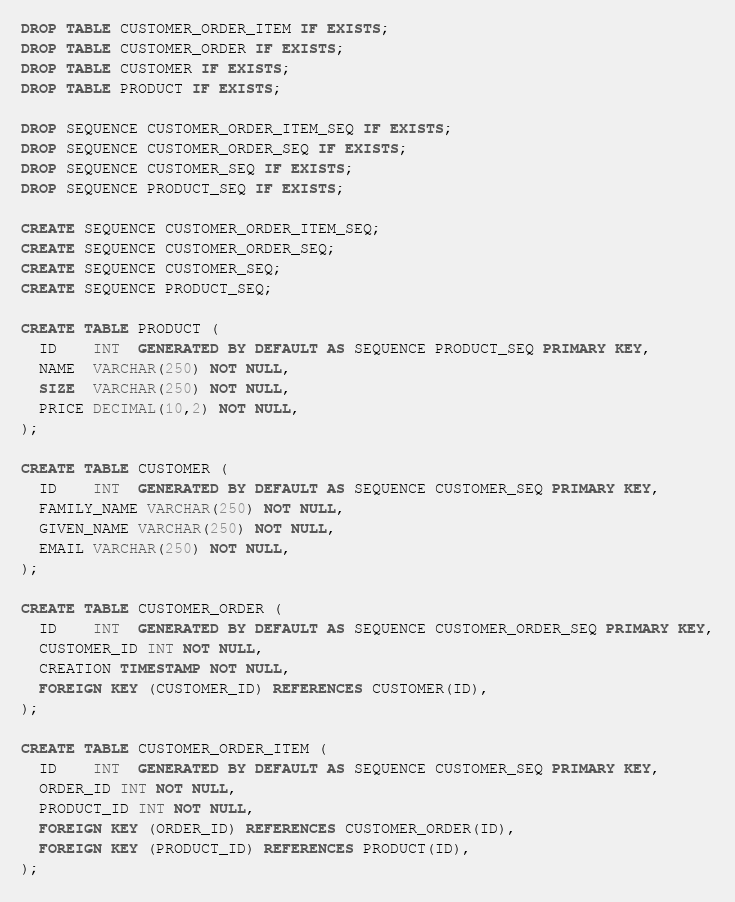Convert code to text. <code><loc_0><loc_0><loc_500><loc_500><_SQL_>DROP TABLE CUSTOMER_ORDER_ITEM IF EXISTS;
DROP TABLE CUSTOMER_ORDER IF EXISTS;
DROP TABLE CUSTOMER IF EXISTS;
DROP TABLE PRODUCT IF EXISTS;

DROP SEQUENCE CUSTOMER_ORDER_ITEM_SEQ IF EXISTS;
DROP SEQUENCE CUSTOMER_ORDER_SEQ IF EXISTS;
DROP SEQUENCE CUSTOMER_SEQ IF EXISTS;
DROP SEQUENCE PRODUCT_SEQ IF EXISTS;

CREATE SEQUENCE CUSTOMER_ORDER_ITEM_SEQ;
CREATE SEQUENCE CUSTOMER_ORDER_SEQ;
CREATE SEQUENCE CUSTOMER_SEQ;
CREATE SEQUENCE PRODUCT_SEQ;

CREATE TABLE PRODUCT (
  ID    INT  GENERATED BY DEFAULT AS SEQUENCE PRODUCT_SEQ PRIMARY KEY,
  NAME  VARCHAR(250) NOT NULL,
  SIZE  VARCHAR(250) NOT NULL,
  PRICE DECIMAL(10,2) NOT NULL,
);

CREATE TABLE CUSTOMER (
  ID    INT  GENERATED BY DEFAULT AS SEQUENCE CUSTOMER_SEQ PRIMARY KEY,
  FAMILY_NAME VARCHAR(250) NOT NULL,
  GIVEN_NAME VARCHAR(250) NOT NULL,
  EMAIL VARCHAR(250) NOT NULL,
);

CREATE TABLE CUSTOMER_ORDER (
  ID    INT  GENERATED BY DEFAULT AS SEQUENCE CUSTOMER_ORDER_SEQ PRIMARY KEY,
  CUSTOMER_ID INT NOT NULL,
  CREATION TIMESTAMP NOT NULL,
  FOREIGN KEY (CUSTOMER_ID) REFERENCES CUSTOMER(ID),
);

CREATE TABLE CUSTOMER_ORDER_ITEM (
  ID    INT  GENERATED BY DEFAULT AS SEQUENCE CUSTOMER_SEQ PRIMARY KEY,
  ORDER_ID INT NOT NULL,
  PRODUCT_ID INT NOT NULL,
  FOREIGN KEY (ORDER_ID) REFERENCES CUSTOMER_ORDER(ID),
  FOREIGN KEY (PRODUCT_ID) REFERENCES PRODUCT(ID),
);
</code> 